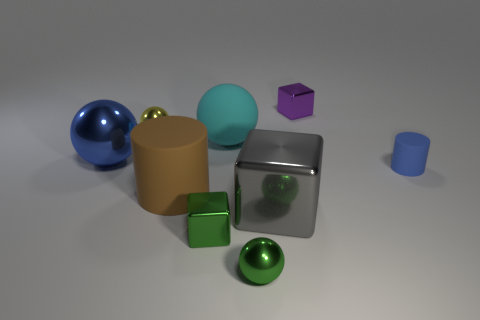Add 1 big metallic objects. How many objects exist? 10 Subtract all balls. How many objects are left? 5 Add 6 rubber things. How many rubber things are left? 9 Add 7 brown matte things. How many brown matte things exist? 8 Subtract 0 yellow cylinders. How many objects are left? 9 Subtract all blue balls. Subtract all yellow spheres. How many objects are left? 7 